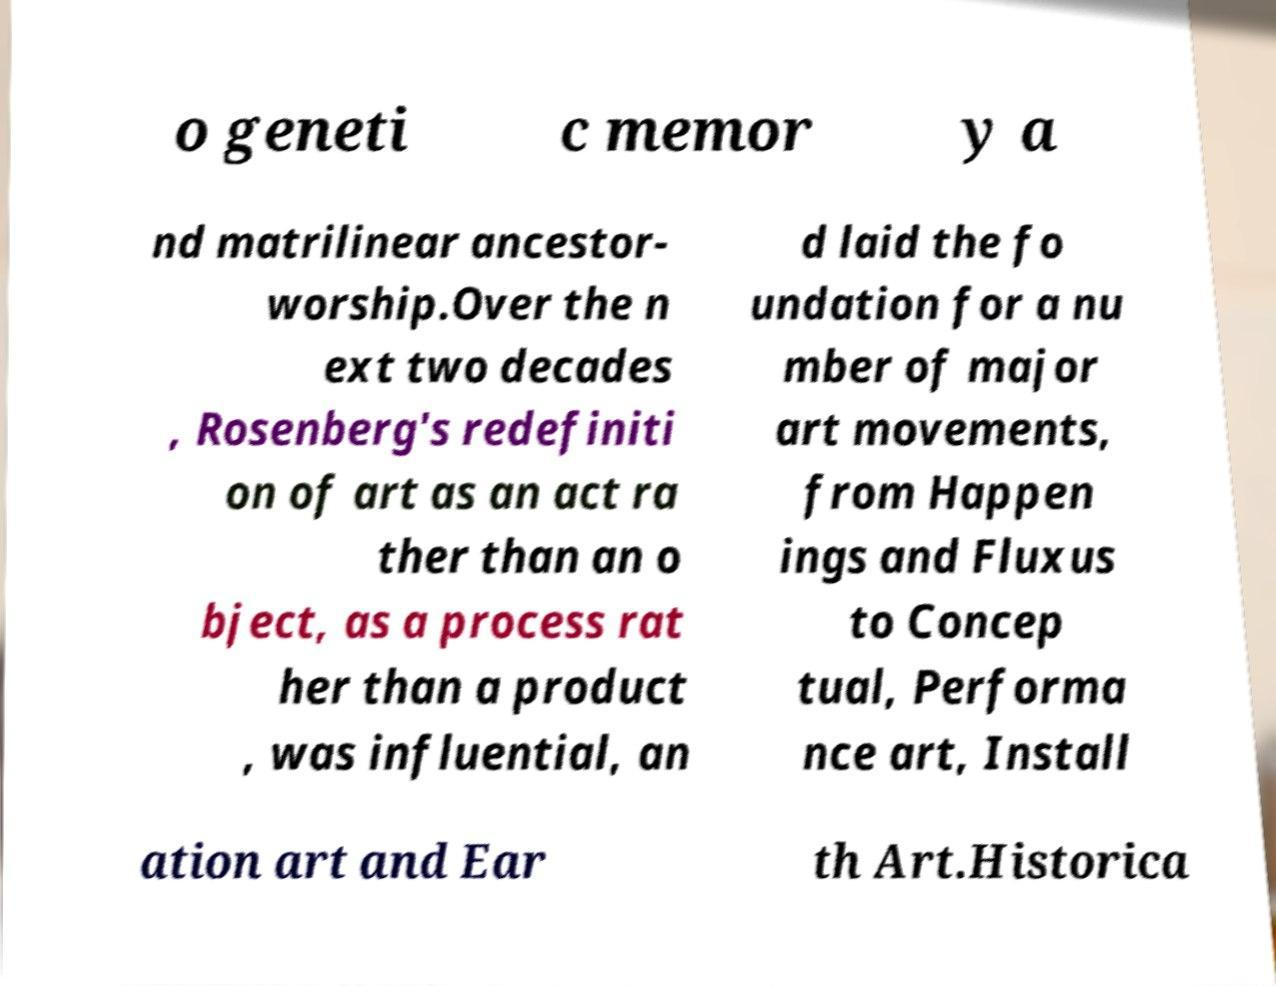For documentation purposes, I need the text within this image transcribed. Could you provide that? o geneti c memor y a nd matrilinear ancestor- worship.Over the n ext two decades , Rosenberg's redefiniti on of art as an act ra ther than an o bject, as a process rat her than a product , was influential, an d laid the fo undation for a nu mber of major art movements, from Happen ings and Fluxus to Concep tual, Performa nce art, Install ation art and Ear th Art.Historica 